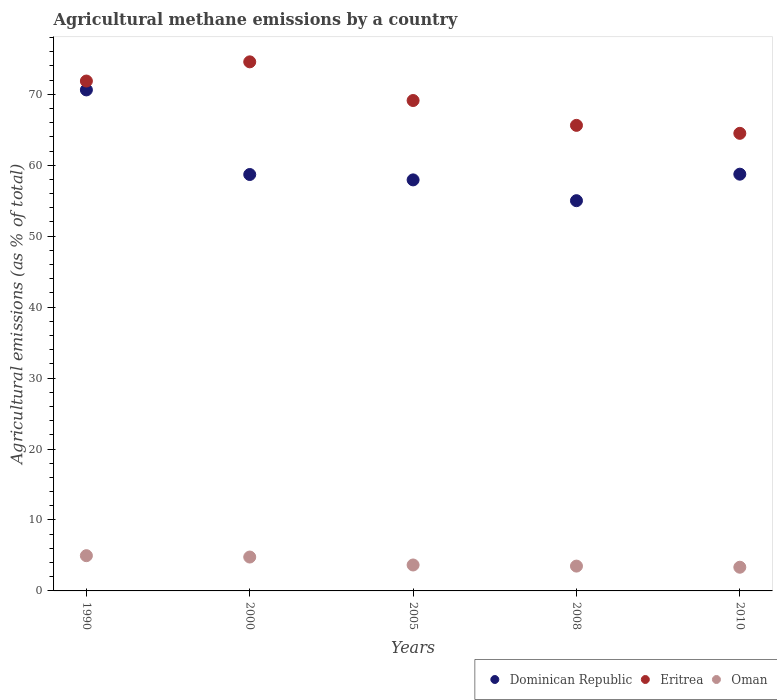How many different coloured dotlines are there?
Make the answer very short. 3. What is the amount of agricultural methane emitted in Oman in 2008?
Ensure brevity in your answer.  3.5. Across all years, what is the maximum amount of agricultural methane emitted in Eritrea?
Offer a terse response. 74.57. Across all years, what is the minimum amount of agricultural methane emitted in Oman?
Ensure brevity in your answer.  3.34. In which year was the amount of agricultural methane emitted in Dominican Republic minimum?
Provide a succinct answer. 2008. What is the total amount of agricultural methane emitted in Oman in the graph?
Provide a succinct answer. 20.24. What is the difference between the amount of agricultural methane emitted in Oman in 2008 and that in 2010?
Your answer should be very brief. 0.16. What is the difference between the amount of agricultural methane emitted in Dominican Republic in 1990 and the amount of agricultural methane emitted in Eritrea in 2010?
Provide a short and direct response. 6.12. What is the average amount of agricultural methane emitted in Eritrea per year?
Ensure brevity in your answer.  69.14. In the year 1990, what is the difference between the amount of agricultural methane emitted in Oman and amount of agricultural methane emitted in Dominican Republic?
Provide a succinct answer. -65.65. What is the ratio of the amount of agricultural methane emitted in Eritrea in 1990 to that in 2000?
Provide a short and direct response. 0.96. Is the amount of agricultural methane emitted in Oman in 1990 less than that in 2000?
Your response must be concise. No. Is the difference between the amount of agricultural methane emitted in Oman in 1990 and 2010 greater than the difference between the amount of agricultural methane emitted in Dominican Republic in 1990 and 2010?
Give a very brief answer. No. What is the difference between the highest and the second highest amount of agricultural methane emitted in Eritrea?
Offer a terse response. 2.71. What is the difference between the highest and the lowest amount of agricultural methane emitted in Dominican Republic?
Provide a succinct answer. 15.61. Is the sum of the amount of agricultural methane emitted in Eritrea in 1990 and 2010 greater than the maximum amount of agricultural methane emitted in Dominican Republic across all years?
Your answer should be very brief. Yes. Is it the case that in every year, the sum of the amount of agricultural methane emitted in Oman and amount of agricultural methane emitted in Eritrea  is greater than the amount of agricultural methane emitted in Dominican Republic?
Give a very brief answer. Yes. Is the amount of agricultural methane emitted in Dominican Republic strictly greater than the amount of agricultural methane emitted in Eritrea over the years?
Your response must be concise. No. Is the amount of agricultural methane emitted in Oman strictly less than the amount of agricultural methane emitted in Dominican Republic over the years?
Offer a very short reply. Yes. How many years are there in the graph?
Provide a succinct answer. 5. What is the difference between two consecutive major ticks on the Y-axis?
Provide a succinct answer. 10. Are the values on the major ticks of Y-axis written in scientific E-notation?
Make the answer very short. No. Does the graph contain any zero values?
Provide a succinct answer. No. Where does the legend appear in the graph?
Your answer should be very brief. Bottom right. How many legend labels are there?
Your answer should be compact. 3. What is the title of the graph?
Your answer should be very brief. Agricultural methane emissions by a country. Does "Serbia" appear as one of the legend labels in the graph?
Your answer should be very brief. No. What is the label or title of the X-axis?
Make the answer very short. Years. What is the label or title of the Y-axis?
Offer a very short reply. Agricultural emissions (as % of total). What is the Agricultural emissions (as % of total) in Dominican Republic in 1990?
Provide a succinct answer. 70.62. What is the Agricultural emissions (as % of total) in Eritrea in 1990?
Provide a short and direct response. 71.87. What is the Agricultural emissions (as % of total) of Oman in 1990?
Your answer should be very brief. 4.97. What is the Agricultural emissions (as % of total) in Dominican Republic in 2000?
Offer a terse response. 58.69. What is the Agricultural emissions (as % of total) in Eritrea in 2000?
Offer a very short reply. 74.57. What is the Agricultural emissions (as % of total) of Oman in 2000?
Your response must be concise. 4.78. What is the Agricultural emissions (as % of total) in Dominican Republic in 2005?
Ensure brevity in your answer.  57.94. What is the Agricultural emissions (as % of total) in Eritrea in 2005?
Your answer should be very brief. 69.12. What is the Agricultural emissions (as % of total) in Oman in 2005?
Ensure brevity in your answer.  3.66. What is the Agricultural emissions (as % of total) in Dominican Republic in 2008?
Give a very brief answer. 55. What is the Agricultural emissions (as % of total) in Eritrea in 2008?
Provide a short and direct response. 65.62. What is the Agricultural emissions (as % of total) in Oman in 2008?
Provide a succinct answer. 3.5. What is the Agricultural emissions (as % of total) of Dominican Republic in 2010?
Offer a terse response. 58.74. What is the Agricultural emissions (as % of total) of Eritrea in 2010?
Your answer should be compact. 64.5. What is the Agricultural emissions (as % of total) of Oman in 2010?
Provide a short and direct response. 3.34. Across all years, what is the maximum Agricultural emissions (as % of total) in Dominican Republic?
Your answer should be compact. 70.62. Across all years, what is the maximum Agricultural emissions (as % of total) of Eritrea?
Give a very brief answer. 74.57. Across all years, what is the maximum Agricultural emissions (as % of total) of Oman?
Your response must be concise. 4.97. Across all years, what is the minimum Agricultural emissions (as % of total) in Dominican Republic?
Ensure brevity in your answer.  55. Across all years, what is the minimum Agricultural emissions (as % of total) in Eritrea?
Your answer should be very brief. 64.5. Across all years, what is the minimum Agricultural emissions (as % of total) of Oman?
Your response must be concise. 3.34. What is the total Agricultural emissions (as % of total) of Dominican Republic in the graph?
Give a very brief answer. 300.99. What is the total Agricultural emissions (as % of total) in Eritrea in the graph?
Your response must be concise. 345.68. What is the total Agricultural emissions (as % of total) of Oman in the graph?
Give a very brief answer. 20.24. What is the difference between the Agricultural emissions (as % of total) in Dominican Republic in 1990 and that in 2000?
Provide a short and direct response. 11.92. What is the difference between the Agricultural emissions (as % of total) in Eritrea in 1990 and that in 2000?
Provide a succinct answer. -2.71. What is the difference between the Agricultural emissions (as % of total) in Oman in 1990 and that in 2000?
Provide a short and direct response. 0.19. What is the difference between the Agricultural emissions (as % of total) of Dominican Republic in 1990 and that in 2005?
Keep it short and to the point. 12.68. What is the difference between the Agricultural emissions (as % of total) in Eritrea in 1990 and that in 2005?
Offer a terse response. 2.75. What is the difference between the Agricultural emissions (as % of total) of Oman in 1990 and that in 2005?
Your answer should be compact. 1.31. What is the difference between the Agricultural emissions (as % of total) in Dominican Republic in 1990 and that in 2008?
Your answer should be compact. 15.61. What is the difference between the Agricultural emissions (as % of total) in Eritrea in 1990 and that in 2008?
Your answer should be compact. 6.25. What is the difference between the Agricultural emissions (as % of total) of Oman in 1990 and that in 2008?
Make the answer very short. 1.47. What is the difference between the Agricultural emissions (as % of total) of Dominican Republic in 1990 and that in 2010?
Ensure brevity in your answer.  11.88. What is the difference between the Agricultural emissions (as % of total) of Eritrea in 1990 and that in 2010?
Offer a very short reply. 7.37. What is the difference between the Agricultural emissions (as % of total) of Oman in 1990 and that in 2010?
Provide a short and direct response. 1.63. What is the difference between the Agricultural emissions (as % of total) in Dominican Republic in 2000 and that in 2005?
Provide a short and direct response. 0.76. What is the difference between the Agricultural emissions (as % of total) in Eritrea in 2000 and that in 2005?
Your response must be concise. 5.45. What is the difference between the Agricultural emissions (as % of total) of Oman in 2000 and that in 2005?
Provide a succinct answer. 1.12. What is the difference between the Agricultural emissions (as % of total) of Dominican Republic in 2000 and that in 2008?
Your response must be concise. 3.69. What is the difference between the Agricultural emissions (as % of total) of Eritrea in 2000 and that in 2008?
Give a very brief answer. 8.95. What is the difference between the Agricultural emissions (as % of total) of Oman in 2000 and that in 2008?
Offer a very short reply. 1.28. What is the difference between the Agricultural emissions (as % of total) in Dominican Republic in 2000 and that in 2010?
Make the answer very short. -0.05. What is the difference between the Agricultural emissions (as % of total) in Eritrea in 2000 and that in 2010?
Keep it short and to the point. 10.08. What is the difference between the Agricultural emissions (as % of total) in Oman in 2000 and that in 2010?
Offer a terse response. 1.44. What is the difference between the Agricultural emissions (as % of total) of Dominican Republic in 2005 and that in 2008?
Provide a short and direct response. 2.93. What is the difference between the Agricultural emissions (as % of total) of Eritrea in 2005 and that in 2008?
Your answer should be compact. 3.5. What is the difference between the Agricultural emissions (as % of total) of Oman in 2005 and that in 2008?
Your answer should be very brief. 0.16. What is the difference between the Agricultural emissions (as % of total) of Dominican Republic in 2005 and that in 2010?
Give a very brief answer. -0.81. What is the difference between the Agricultural emissions (as % of total) in Eritrea in 2005 and that in 2010?
Ensure brevity in your answer.  4.63. What is the difference between the Agricultural emissions (as % of total) in Oman in 2005 and that in 2010?
Your response must be concise. 0.32. What is the difference between the Agricultural emissions (as % of total) of Dominican Republic in 2008 and that in 2010?
Give a very brief answer. -3.74. What is the difference between the Agricultural emissions (as % of total) in Eritrea in 2008 and that in 2010?
Your response must be concise. 1.12. What is the difference between the Agricultural emissions (as % of total) of Oman in 2008 and that in 2010?
Your answer should be compact. 0.16. What is the difference between the Agricultural emissions (as % of total) of Dominican Republic in 1990 and the Agricultural emissions (as % of total) of Eritrea in 2000?
Provide a short and direct response. -3.96. What is the difference between the Agricultural emissions (as % of total) in Dominican Republic in 1990 and the Agricultural emissions (as % of total) in Oman in 2000?
Make the answer very short. 65.84. What is the difference between the Agricultural emissions (as % of total) of Eritrea in 1990 and the Agricultural emissions (as % of total) of Oman in 2000?
Your answer should be compact. 67.09. What is the difference between the Agricultural emissions (as % of total) of Dominican Republic in 1990 and the Agricultural emissions (as % of total) of Eritrea in 2005?
Make the answer very short. 1.5. What is the difference between the Agricultural emissions (as % of total) in Dominican Republic in 1990 and the Agricultural emissions (as % of total) in Oman in 2005?
Keep it short and to the point. 66.96. What is the difference between the Agricultural emissions (as % of total) in Eritrea in 1990 and the Agricultural emissions (as % of total) in Oman in 2005?
Provide a succinct answer. 68.21. What is the difference between the Agricultural emissions (as % of total) in Dominican Republic in 1990 and the Agricultural emissions (as % of total) in Eritrea in 2008?
Give a very brief answer. 5. What is the difference between the Agricultural emissions (as % of total) of Dominican Republic in 1990 and the Agricultural emissions (as % of total) of Oman in 2008?
Your answer should be very brief. 67.12. What is the difference between the Agricultural emissions (as % of total) in Eritrea in 1990 and the Agricultural emissions (as % of total) in Oman in 2008?
Keep it short and to the point. 68.37. What is the difference between the Agricultural emissions (as % of total) in Dominican Republic in 1990 and the Agricultural emissions (as % of total) in Eritrea in 2010?
Provide a succinct answer. 6.12. What is the difference between the Agricultural emissions (as % of total) in Dominican Republic in 1990 and the Agricultural emissions (as % of total) in Oman in 2010?
Offer a very short reply. 67.28. What is the difference between the Agricultural emissions (as % of total) in Eritrea in 1990 and the Agricultural emissions (as % of total) in Oman in 2010?
Offer a very short reply. 68.53. What is the difference between the Agricultural emissions (as % of total) in Dominican Republic in 2000 and the Agricultural emissions (as % of total) in Eritrea in 2005?
Your answer should be very brief. -10.43. What is the difference between the Agricultural emissions (as % of total) in Dominican Republic in 2000 and the Agricultural emissions (as % of total) in Oman in 2005?
Provide a succinct answer. 55.04. What is the difference between the Agricultural emissions (as % of total) in Eritrea in 2000 and the Agricultural emissions (as % of total) in Oman in 2005?
Your answer should be very brief. 70.92. What is the difference between the Agricultural emissions (as % of total) in Dominican Republic in 2000 and the Agricultural emissions (as % of total) in Eritrea in 2008?
Offer a very short reply. -6.93. What is the difference between the Agricultural emissions (as % of total) of Dominican Republic in 2000 and the Agricultural emissions (as % of total) of Oman in 2008?
Keep it short and to the point. 55.2. What is the difference between the Agricultural emissions (as % of total) in Eritrea in 2000 and the Agricultural emissions (as % of total) in Oman in 2008?
Provide a short and direct response. 71.07. What is the difference between the Agricultural emissions (as % of total) of Dominican Republic in 2000 and the Agricultural emissions (as % of total) of Eritrea in 2010?
Ensure brevity in your answer.  -5.8. What is the difference between the Agricultural emissions (as % of total) of Dominican Republic in 2000 and the Agricultural emissions (as % of total) of Oman in 2010?
Make the answer very short. 55.36. What is the difference between the Agricultural emissions (as % of total) in Eritrea in 2000 and the Agricultural emissions (as % of total) in Oman in 2010?
Offer a very short reply. 71.24. What is the difference between the Agricultural emissions (as % of total) in Dominican Republic in 2005 and the Agricultural emissions (as % of total) in Eritrea in 2008?
Give a very brief answer. -7.69. What is the difference between the Agricultural emissions (as % of total) in Dominican Republic in 2005 and the Agricultural emissions (as % of total) in Oman in 2008?
Offer a very short reply. 54.44. What is the difference between the Agricultural emissions (as % of total) in Eritrea in 2005 and the Agricultural emissions (as % of total) in Oman in 2008?
Your answer should be compact. 65.62. What is the difference between the Agricultural emissions (as % of total) of Dominican Republic in 2005 and the Agricultural emissions (as % of total) of Eritrea in 2010?
Ensure brevity in your answer.  -6.56. What is the difference between the Agricultural emissions (as % of total) of Dominican Republic in 2005 and the Agricultural emissions (as % of total) of Oman in 2010?
Offer a terse response. 54.6. What is the difference between the Agricultural emissions (as % of total) in Eritrea in 2005 and the Agricultural emissions (as % of total) in Oman in 2010?
Provide a short and direct response. 65.78. What is the difference between the Agricultural emissions (as % of total) in Dominican Republic in 2008 and the Agricultural emissions (as % of total) in Eritrea in 2010?
Keep it short and to the point. -9.49. What is the difference between the Agricultural emissions (as % of total) of Dominican Republic in 2008 and the Agricultural emissions (as % of total) of Oman in 2010?
Offer a very short reply. 51.67. What is the difference between the Agricultural emissions (as % of total) of Eritrea in 2008 and the Agricultural emissions (as % of total) of Oman in 2010?
Your answer should be compact. 62.28. What is the average Agricultural emissions (as % of total) of Dominican Republic per year?
Offer a terse response. 60.2. What is the average Agricultural emissions (as % of total) of Eritrea per year?
Your answer should be compact. 69.14. What is the average Agricultural emissions (as % of total) of Oman per year?
Offer a very short reply. 4.05. In the year 1990, what is the difference between the Agricultural emissions (as % of total) of Dominican Republic and Agricultural emissions (as % of total) of Eritrea?
Your response must be concise. -1.25. In the year 1990, what is the difference between the Agricultural emissions (as % of total) in Dominican Republic and Agricultural emissions (as % of total) in Oman?
Provide a short and direct response. 65.65. In the year 1990, what is the difference between the Agricultural emissions (as % of total) in Eritrea and Agricultural emissions (as % of total) in Oman?
Provide a succinct answer. 66.9. In the year 2000, what is the difference between the Agricultural emissions (as % of total) in Dominican Republic and Agricultural emissions (as % of total) in Eritrea?
Make the answer very short. -15.88. In the year 2000, what is the difference between the Agricultural emissions (as % of total) of Dominican Republic and Agricultural emissions (as % of total) of Oman?
Provide a succinct answer. 53.92. In the year 2000, what is the difference between the Agricultural emissions (as % of total) in Eritrea and Agricultural emissions (as % of total) in Oman?
Provide a short and direct response. 69.8. In the year 2005, what is the difference between the Agricultural emissions (as % of total) of Dominican Republic and Agricultural emissions (as % of total) of Eritrea?
Your answer should be compact. -11.19. In the year 2005, what is the difference between the Agricultural emissions (as % of total) in Dominican Republic and Agricultural emissions (as % of total) in Oman?
Ensure brevity in your answer.  54.28. In the year 2005, what is the difference between the Agricultural emissions (as % of total) in Eritrea and Agricultural emissions (as % of total) in Oman?
Give a very brief answer. 65.47. In the year 2008, what is the difference between the Agricultural emissions (as % of total) of Dominican Republic and Agricultural emissions (as % of total) of Eritrea?
Offer a terse response. -10.62. In the year 2008, what is the difference between the Agricultural emissions (as % of total) in Dominican Republic and Agricultural emissions (as % of total) in Oman?
Keep it short and to the point. 51.51. In the year 2008, what is the difference between the Agricultural emissions (as % of total) of Eritrea and Agricultural emissions (as % of total) of Oman?
Your answer should be compact. 62.12. In the year 2010, what is the difference between the Agricultural emissions (as % of total) of Dominican Republic and Agricultural emissions (as % of total) of Eritrea?
Provide a succinct answer. -5.76. In the year 2010, what is the difference between the Agricultural emissions (as % of total) of Dominican Republic and Agricultural emissions (as % of total) of Oman?
Make the answer very short. 55.4. In the year 2010, what is the difference between the Agricultural emissions (as % of total) of Eritrea and Agricultural emissions (as % of total) of Oman?
Your answer should be compact. 61.16. What is the ratio of the Agricultural emissions (as % of total) in Dominican Republic in 1990 to that in 2000?
Make the answer very short. 1.2. What is the ratio of the Agricultural emissions (as % of total) of Eritrea in 1990 to that in 2000?
Make the answer very short. 0.96. What is the ratio of the Agricultural emissions (as % of total) in Oman in 1990 to that in 2000?
Offer a terse response. 1.04. What is the ratio of the Agricultural emissions (as % of total) in Dominican Republic in 1990 to that in 2005?
Give a very brief answer. 1.22. What is the ratio of the Agricultural emissions (as % of total) of Eritrea in 1990 to that in 2005?
Offer a very short reply. 1.04. What is the ratio of the Agricultural emissions (as % of total) of Oman in 1990 to that in 2005?
Offer a very short reply. 1.36. What is the ratio of the Agricultural emissions (as % of total) of Dominican Republic in 1990 to that in 2008?
Your response must be concise. 1.28. What is the ratio of the Agricultural emissions (as % of total) in Eritrea in 1990 to that in 2008?
Ensure brevity in your answer.  1.1. What is the ratio of the Agricultural emissions (as % of total) in Oman in 1990 to that in 2008?
Keep it short and to the point. 1.42. What is the ratio of the Agricultural emissions (as % of total) in Dominican Republic in 1990 to that in 2010?
Provide a short and direct response. 1.2. What is the ratio of the Agricultural emissions (as % of total) in Eritrea in 1990 to that in 2010?
Your answer should be very brief. 1.11. What is the ratio of the Agricultural emissions (as % of total) of Oman in 1990 to that in 2010?
Give a very brief answer. 1.49. What is the ratio of the Agricultural emissions (as % of total) in Dominican Republic in 2000 to that in 2005?
Make the answer very short. 1.01. What is the ratio of the Agricultural emissions (as % of total) of Eritrea in 2000 to that in 2005?
Keep it short and to the point. 1.08. What is the ratio of the Agricultural emissions (as % of total) of Oman in 2000 to that in 2005?
Offer a terse response. 1.31. What is the ratio of the Agricultural emissions (as % of total) of Dominican Republic in 2000 to that in 2008?
Make the answer very short. 1.07. What is the ratio of the Agricultural emissions (as % of total) of Eritrea in 2000 to that in 2008?
Your answer should be compact. 1.14. What is the ratio of the Agricultural emissions (as % of total) in Oman in 2000 to that in 2008?
Your answer should be very brief. 1.36. What is the ratio of the Agricultural emissions (as % of total) in Eritrea in 2000 to that in 2010?
Keep it short and to the point. 1.16. What is the ratio of the Agricultural emissions (as % of total) of Oman in 2000 to that in 2010?
Make the answer very short. 1.43. What is the ratio of the Agricultural emissions (as % of total) of Dominican Republic in 2005 to that in 2008?
Give a very brief answer. 1.05. What is the ratio of the Agricultural emissions (as % of total) in Eritrea in 2005 to that in 2008?
Give a very brief answer. 1.05. What is the ratio of the Agricultural emissions (as % of total) of Oman in 2005 to that in 2008?
Give a very brief answer. 1.04. What is the ratio of the Agricultural emissions (as % of total) in Dominican Republic in 2005 to that in 2010?
Keep it short and to the point. 0.99. What is the ratio of the Agricultural emissions (as % of total) in Eritrea in 2005 to that in 2010?
Make the answer very short. 1.07. What is the ratio of the Agricultural emissions (as % of total) in Oman in 2005 to that in 2010?
Offer a terse response. 1.09. What is the ratio of the Agricultural emissions (as % of total) of Dominican Republic in 2008 to that in 2010?
Keep it short and to the point. 0.94. What is the ratio of the Agricultural emissions (as % of total) in Eritrea in 2008 to that in 2010?
Provide a short and direct response. 1.02. What is the ratio of the Agricultural emissions (as % of total) of Oman in 2008 to that in 2010?
Give a very brief answer. 1.05. What is the difference between the highest and the second highest Agricultural emissions (as % of total) of Dominican Republic?
Make the answer very short. 11.88. What is the difference between the highest and the second highest Agricultural emissions (as % of total) in Eritrea?
Give a very brief answer. 2.71. What is the difference between the highest and the second highest Agricultural emissions (as % of total) of Oman?
Ensure brevity in your answer.  0.19. What is the difference between the highest and the lowest Agricultural emissions (as % of total) of Dominican Republic?
Offer a very short reply. 15.61. What is the difference between the highest and the lowest Agricultural emissions (as % of total) in Eritrea?
Provide a succinct answer. 10.08. What is the difference between the highest and the lowest Agricultural emissions (as % of total) of Oman?
Give a very brief answer. 1.63. 